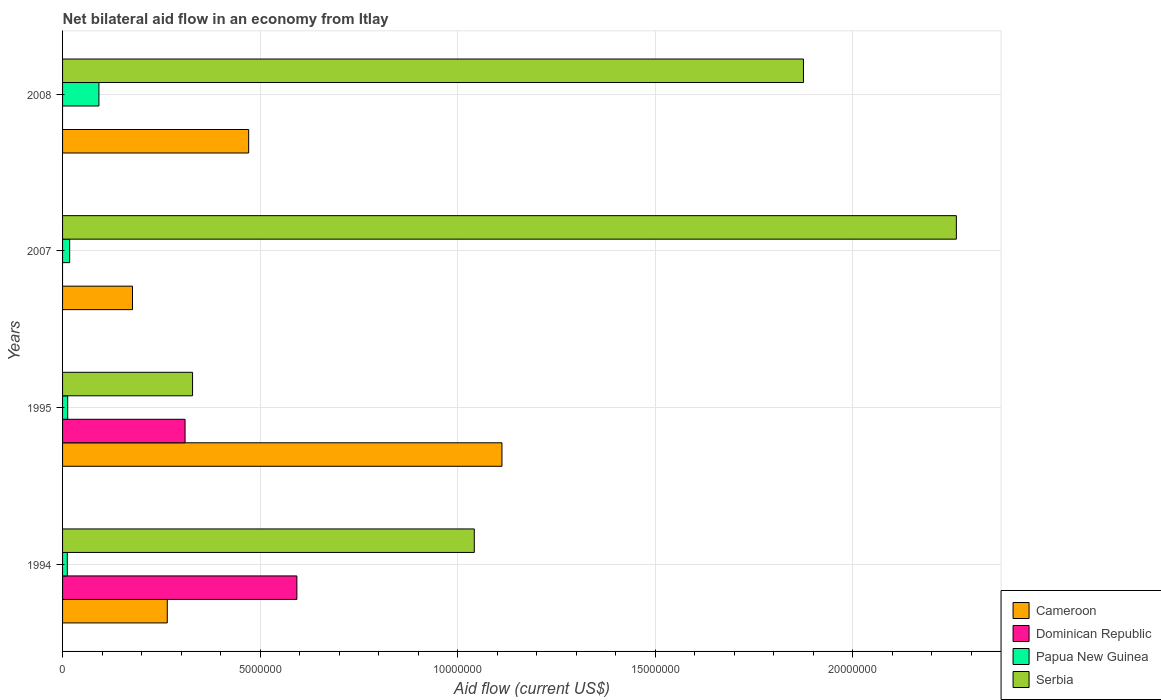Are the number of bars per tick equal to the number of legend labels?
Offer a very short reply. No. How many bars are there on the 4th tick from the top?
Your answer should be compact. 4. How many bars are there on the 3rd tick from the bottom?
Offer a terse response. 3. What is the label of the 1st group of bars from the top?
Provide a short and direct response. 2008. In how many cases, is the number of bars for a given year not equal to the number of legend labels?
Ensure brevity in your answer.  2. What is the net bilateral aid flow in Serbia in 1995?
Offer a very short reply. 3.29e+06. Across all years, what is the maximum net bilateral aid flow in Dominican Republic?
Offer a very short reply. 5.93e+06. What is the total net bilateral aid flow in Dominican Republic in the graph?
Offer a terse response. 9.03e+06. What is the difference between the net bilateral aid flow in Serbia in 1994 and that in 1995?
Make the answer very short. 7.13e+06. What is the difference between the net bilateral aid flow in Serbia in 1994 and the net bilateral aid flow in Cameroon in 2007?
Offer a terse response. 8.65e+06. What is the average net bilateral aid flow in Dominican Republic per year?
Keep it short and to the point. 2.26e+06. In the year 1995, what is the difference between the net bilateral aid flow in Serbia and net bilateral aid flow in Papua New Guinea?
Your answer should be very brief. 3.16e+06. In how many years, is the net bilateral aid flow in Serbia greater than 16000000 US$?
Your answer should be compact. 2. What is the ratio of the net bilateral aid flow in Papua New Guinea in 1995 to that in 2008?
Ensure brevity in your answer.  0.14. What is the difference between the highest and the second highest net bilateral aid flow in Papua New Guinea?
Keep it short and to the point. 7.40e+05. What is the difference between the highest and the lowest net bilateral aid flow in Serbia?
Offer a terse response. 1.93e+07. In how many years, is the net bilateral aid flow in Dominican Republic greater than the average net bilateral aid flow in Dominican Republic taken over all years?
Keep it short and to the point. 2. Are all the bars in the graph horizontal?
Provide a short and direct response. Yes. How many years are there in the graph?
Offer a very short reply. 4. Does the graph contain any zero values?
Your answer should be compact. Yes. Does the graph contain grids?
Your answer should be very brief. Yes. Where does the legend appear in the graph?
Provide a succinct answer. Bottom right. How many legend labels are there?
Ensure brevity in your answer.  4. What is the title of the graph?
Make the answer very short. Net bilateral aid flow in an economy from Itlay. What is the Aid flow (current US$) of Cameroon in 1994?
Give a very brief answer. 2.65e+06. What is the Aid flow (current US$) of Dominican Republic in 1994?
Offer a terse response. 5.93e+06. What is the Aid flow (current US$) of Serbia in 1994?
Give a very brief answer. 1.04e+07. What is the Aid flow (current US$) of Cameroon in 1995?
Offer a terse response. 1.11e+07. What is the Aid flow (current US$) in Dominican Republic in 1995?
Make the answer very short. 3.10e+06. What is the Aid flow (current US$) in Papua New Guinea in 1995?
Offer a terse response. 1.30e+05. What is the Aid flow (current US$) of Serbia in 1995?
Provide a short and direct response. 3.29e+06. What is the Aid flow (current US$) of Cameroon in 2007?
Your answer should be compact. 1.77e+06. What is the Aid flow (current US$) in Dominican Republic in 2007?
Ensure brevity in your answer.  0. What is the Aid flow (current US$) of Serbia in 2007?
Ensure brevity in your answer.  2.26e+07. What is the Aid flow (current US$) of Cameroon in 2008?
Your answer should be compact. 4.71e+06. What is the Aid flow (current US$) in Dominican Republic in 2008?
Your answer should be very brief. 0. What is the Aid flow (current US$) of Papua New Guinea in 2008?
Your response must be concise. 9.20e+05. What is the Aid flow (current US$) in Serbia in 2008?
Offer a very short reply. 1.88e+07. Across all years, what is the maximum Aid flow (current US$) of Cameroon?
Ensure brevity in your answer.  1.11e+07. Across all years, what is the maximum Aid flow (current US$) of Dominican Republic?
Your response must be concise. 5.93e+06. Across all years, what is the maximum Aid flow (current US$) in Papua New Guinea?
Your response must be concise. 9.20e+05. Across all years, what is the maximum Aid flow (current US$) of Serbia?
Offer a terse response. 2.26e+07. Across all years, what is the minimum Aid flow (current US$) of Cameroon?
Provide a short and direct response. 1.77e+06. Across all years, what is the minimum Aid flow (current US$) in Serbia?
Offer a very short reply. 3.29e+06. What is the total Aid flow (current US$) in Cameroon in the graph?
Your answer should be compact. 2.02e+07. What is the total Aid flow (current US$) in Dominican Republic in the graph?
Provide a short and direct response. 9.03e+06. What is the total Aid flow (current US$) of Papua New Guinea in the graph?
Keep it short and to the point. 1.35e+06. What is the total Aid flow (current US$) in Serbia in the graph?
Make the answer very short. 5.51e+07. What is the difference between the Aid flow (current US$) in Cameroon in 1994 and that in 1995?
Offer a very short reply. -8.47e+06. What is the difference between the Aid flow (current US$) of Dominican Republic in 1994 and that in 1995?
Provide a succinct answer. 2.83e+06. What is the difference between the Aid flow (current US$) in Papua New Guinea in 1994 and that in 1995?
Offer a very short reply. -10000. What is the difference between the Aid flow (current US$) in Serbia in 1994 and that in 1995?
Give a very brief answer. 7.13e+06. What is the difference between the Aid flow (current US$) of Cameroon in 1994 and that in 2007?
Your answer should be compact. 8.80e+05. What is the difference between the Aid flow (current US$) in Serbia in 1994 and that in 2007?
Offer a terse response. -1.22e+07. What is the difference between the Aid flow (current US$) of Cameroon in 1994 and that in 2008?
Offer a very short reply. -2.06e+06. What is the difference between the Aid flow (current US$) of Papua New Guinea in 1994 and that in 2008?
Ensure brevity in your answer.  -8.00e+05. What is the difference between the Aid flow (current US$) in Serbia in 1994 and that in 2008?
Your answer should be compact. -8.33e+06. What is the difference between the Aid flow (current US$) of Cameroon in 1995 and that in 2007?
Your answer should be very brief. 9.35e+06. What is the difference between the Aid flow (current US$) in Papua New Guinea in 1995 and that in 2007?
Provide a short and direct response. -5.00e+04. What is the difference between the Aid flow (current US$) of Serbia in 1995 and that in 2007?
Keep it short and to the point. -1.93e+07. What is the difference between the Aid flow (current US$) in Cameroon in 1995 and that in 2008?
Provide a succinct answer. 6.41e+06. What is the difference between the Aid flow (current US$) of Papua New Guinea in 1995 and that in 2008?
Offer a terse response. -7.90e+05. What is the difference between the Aid flow (current US$) in Serbia in 1995 and that in 2008?
Give a very brief answer. -1.55e+07. What is the difference between the Aid flow (current US$) of Cameroon in 2007 and that in 2008?
Keep it short and to the point. -2.94e+06. What is the difference between the Aid flow (current US$) of Papua New Guinea in 2007 and that in 2008?
Your answer should be compact. -7.40e+05. What is the difference between the Aid flow (current US$) of Serbia in 2007 and that in 2008?
Your response must be concise. 3.87e+06. What is the difference between the Aid flow (current US$) of Cameroon in 1994 and the Aid flow (current US$) of Dominican Republic in 1995?
Your response must be concise. -4.50e+05. What is the difference between the Aid flow (current US$) in Cameroon in 1994 and the Aid flow (current US$) in Papua New Guinea in 1995?
Your answer should be compact. 2.52e+06. What is the difference between the Aid flow (current US$) in Cameroon in 1994 and the Aid flow (current US$) in Serbia in 1995?
Offer a very short reply. -6.40e+05. What is the difference between the Aid flow (current US$) in Dominican Republic in 1994 and the Aid flow (current US$) in Papua New Guinea in 1995?
Offer a very short reply. 5.80e+06. What is the difference between the Aid flow (current US$) in Dominican Republic in 1994 and the Aid flow (current US$) in Serbia in 1995?
Offer a very short reply. 2.64e+06. What is the difference between the Aid flow (current US$) of Papua New Guinea in 1994 and the Aid flow (current US$) of Serbia in 1995?
Make the answer very short. -3.17e+06. What is the difference between the Aid flow (current US$) in Cameroon in 1994 and the Aid flow (current US$) in Papua New Guinea in 2007?
Your answer should be very brief. 2.47e+06. What is the difference between the Aid flow (current US$) of Cameroon in 1994 and the Aid flow (current US$) of Serbia in 2007?
Offer a very short reply. -2.00e+07. What is the difference between the Aid flow (current US$) of Dominican Republic in 1994 and the Aid flow (current US$) of Papua New Guinea in 2007?
Give a very brief answer. 5.75e+06. What is the difference between the Aid flow (current US$) of Dominican Republic in 1994 and the Aid flow (current US$) of Serbia in 2007?
Your response must be concise. -1.67e+07. What is the difference between the Aid flow (current US$) in Papua New Guinea in 1994 and the Aid flow (current US$) in Serbia in 2007?
Your answer should be very brief. -2.25e+07. What is the difference between the Aid flow (current US$) in Cameroon in 1994 and the Aid flow (current US$) in Papua New Guinea in 2008?
Offer a very short reply. 1.73e+06. What is the difference between the Aid flow (current US$) of Cameroon in 1994 and the Aid flow (current US$) of Serbia in 2008?
Your answer should be compact. -1.61e+07. What is the difference between the Aid flow (current US$) in Dominican Republic in 1994 and the Aid flow (current US$) in Papua New Guinea in 2008?
Your response must be concise. 5.01e+06. What is the difference between the Aid flow (current US$) in Dominican Republic in 1994 and the Aid flow (current US$) in Serbia in 2008?
Make the answer very short. -1.28e+07. What is the difference between the Aid flow (current US$) of Papua New Guinea in 1994 and the Aid flow (current US$) of Serbia in 2008?
Your response must be concise. -1.86e+07. What is the difference between the Aid flow (current US$) in Cameroon in 1995 and the Aid flow (current US$) in Papua New Guinea in 2007?
Ensure brevity in your answer.  1.09e+07. What is the difference between the Aid flow (current US$) in Cameroon in 1995 and the Aid flow (current US$) in Serbia in 2007?
Offer a terse response. -1.15e+07. What is the difference between the Aid flow (current US$) in Dominican Republic in 1995 and the Aid flow (current US$) in Papua New Guinea in 2007?
Provide a short and direct response. 2.92e+06. What is the difference between the Aid flow (current US$) in Dominican Republic in 1995 and the Aid flow (current US$) in Serbia in 2007?
Provide a short and direct response. -1.95e+07. What is the difference between the Aid flow (current US$) of Papua New Guinea in 1995 and the Aid flow (current US$) of Serbia in 2007?
Make the answer very short. -2.25e+07. What is the difference between the Aid flow (current US$) of Cameroon in 1995 and the Aid flow (current US$) of Papua New Guinea in 2008?
Your answer should be compact. 1.02e+07. What is the difference between the Aid flow (current US$) of Cameroon in 1995 and the Aid flow (current US$) of Serbia in 2008?
Provide a succinct answer. -7.63e+06. What is the difference between the Aid flow (current US$) of Dominican Republic in 1995 and the Aid flow (current US$) of Papua New Guinea in 2008?
Make the answer very short. 2.18e+06. What is the difference between the Aid flow (current US$) in Dominican Republic in 1995 and the Aid flow (current US$) in Serbia in 2008?
Make the answer very short. -1.56e+07. What is the difference between the Aid flow (current US$) of Papua New Guinea in 1995 and the Aid flow (current US$) of Serbia in 2008?
Keep it short and to the point. -1.86e+07. What is the difference between the Aid flow (current US$) of Cameroon in 2007 and the Aid flow (current US$) of Papua New Guinea in 2008?
Offer a terse response. 8.50e+05. What is the difference between the Aid flow (current US$) of Cameroon in 2007 and the Aid flow (current US$) of Serbia in 2008?
Provide a short and direct response. -1.70e+07. What is the difference between the Aid flow (current US$) in Papua New Guinea in 2007 and the Aid flow (current US$) in Serbia in 2008?
Your answer should be very brief. -1.86e+07. What is the average Aid flow (current US$) of Cameroon per year?
Offer a very short reply. 5.06e+06. What is the average Aid flow (current US$) in Dominican Republic per year?
Your response must be concise. 2.26e+06. What is the average Aid flow (current US$) of Papua New Guinea per year?
Your answer should be very brief. 3.38e+05. What is the average Aid flow (current US$) in Serbia per year?
Your response must be concise. 1.38e+07. In the year 1994, what is the difference between the Aid flow (current US$) of Cameroon and Aid flow (current US$) of Dominican Republic?
Provide a succinct answer. -3.28e+06. In the year 1994, what is the difference between the Aid flow (current US$) in Cameroon and Aid flow (current US$) in Papua New Guinea?
Provide a succinct answer. 2.53e+06. In the year 1994, what is the difference between the Aid flow (current US$) in Cameroon and Aid flow (current US$) in Serbia?
Provide a succinct answer. -7.77e+06. In the year 1994, what is the difference between the Aid flow (current US$) of Dominican Republic and Aid flow (current US$) of Papua New Guinea?
Make the answer very short. 5.81e+06. In the year 1994, what is the difference between the Aid flow (current US$) of Dominican Republic and Aid flow (current US$) of Serbia?
Keep it short and to the point. -4.49e+06. In the year 1994, what is the difference between the Aid flow (current US$) of Papua New Guinea and Aid flow (current US$) of Serbia?
Offer a terse response. -1.03e+07. In the year 1995, what is the difference between the Aid flow (current US$) of Cameroon and Aid flow (current US$) of Dominican Republic?
Provide a succinct answer. 8.02e+06. In the year 1995, what is the difference between the Aid flow (current US$) of Cameroon and Aid flow (current US$) of Papua New Guinea?
Keep it short and to the point. 1.10e+07. In the year 1995, what is the difference between the Aid flow (current US$) in Cameroon and Aid flow (current US$) in Serbia?
Give a very brief answer. 7.83e+06. In the year 1995, what is the difference between the Aid flow (current US$) of Dominican Republic and Aid flow (current US$) of Papua New Guinea?
Make the answer very short. 2.97e+06. In the year 1995, what is the difference between the Aid flow (current US$) in Papua New Guinea and Aid flow (current US$) in Serbia?
Provide a short and direct response. -3.16e+06. In the year 2007, what is the difference between the Aid flow (current US$) in Cameroon and Aid flow (current US$) in Papua New Guinea?
Your response must be concise. 1.59e+06. In the year 2007, what is the difference between the Aid flow (current US$) of Cameroon and Aid flow (current US$) of Serbia?
Provide a short and direct response. -2.08e+07. In the year 2007, what is the difference between the Aid flow (current US$) of Papua New Guinea and Aid flow (current US$) of Serbia?
Offer a terse response. -2.24e+07. In the year 2008, what is the difference between the Aid flow (current US$) in Cameroon and Aid flow (current US$) in Papua New Guinea?
Your response must be concise. 3.79e+06. In the year 2008, what is the difference between the Aid flow (current US$) in Cameroon and Aid flow (current US$) in Serbia?
Make the answer very short. -1.40e+07. In the year 2008, what is the difference between the Aid flow (current US$) in Papua New Guinea and Aid flow (current US$) in Serbia?
Offer a terse response. -1.78e+07. What is the ratio of the Aid flow (current US$) in Cameroon in 1994 to that in 1995?
Make the answer very short. 0.24. What is the ratio of the Aid flow (current US$) of Dominican Republic in 1994 to that in 1995?
Your answer should be compact. 1.91. What is the ratio of the Aid flow (current US$) of Serbia in 1994 to that in 1995?
Your answer should be compact. 3.17. What is the ratio of the Aid flow (current US$) of Cameroon in 1994 to that in 2007?
Provide a short and direct response. 1.5. What is the ratio of the Aid flow (current US$) of Serbia in 1994 to that in 2007?
Offer a terse response. 0.46. What is the ratio of the Aid flow (current US$) in Cameroon in 1994 to that in 2008?
Offer a very short reply. 0.56. What is the ratio of the Aid flow (current US$) of Papua New Guinea in 1994 to that in 2008?
Offer a terse response. 0.13. What is the ratio of the Aid flow (current US$) of Serbia in 1994 to that in 2008?
Offer a very short reply. 0.56. What is the ratio of the Aid flow (current US$) in Cameroon in 1995 to that in 2007?
Your response must be concise. 6.28. What is the ratio of the Aid flow (current US$) of Papua New Guinea in 1995 to that in 2007?
Give a very brief answer. 0.72. What is the ratio of the Aid flow (current US$) of Serbia in 1995 to that in 2007?
Give a very brief answer. 0.15. What is the ratio of the Aid flow (current US$) in Cameroon in 1995 to that in 2008?
Ensure brevity in your answer.  2.36. What is the ratio of the Aid flow (current US$) of Papua New Guinea in 1995 to that in 2008?
Make the answer very short. 0.14. What is the ratio of the Aid flow (current US$) of Serbia in 1995 to that in 2008?
Your response must be concise. 0.18. What is the ratio of the Aid flow (current US$) of Cameroon in 2007 to that in 2008?
Your response must be concise. 0.38. What is the ratio of the Aid flow (current US$) of Papua New Guinea in 2007 to that in 2008?
Offer a very short reply. 0.2. What is the ratio of the Aid flow (current US$) of Serbia in 2007 to that in 2008?
Keep it short and to the point. 1.21. What is the difference between the highest and the second highest Aid flow (current US$) of Cameroon?
Give a very brief answer. 6.41e+06. What is the difference between the highest and the second highest Aid flow (current US$) in Papua New Guinea?
Your response must be concise. 7.40e+05. What is the difference between the highest and the second highest Aid flow (current US$) in Serbia?
Give a very brief answer. 3.87e+06. What is the difference between the highest and the lowest Aid flow (current US$) of Cameroon?
Ensure brevity in your answer.  9.35e+06. What is the difference between the highest and the lowest Aid flow (current US$) of Dominican Republic?
Give a very brief answer. 5.93e+06. What is the difference between the highest and the lowest Aid flow (current US$) of Serbia?
Provide a short and direct response. 1.93e+07. 